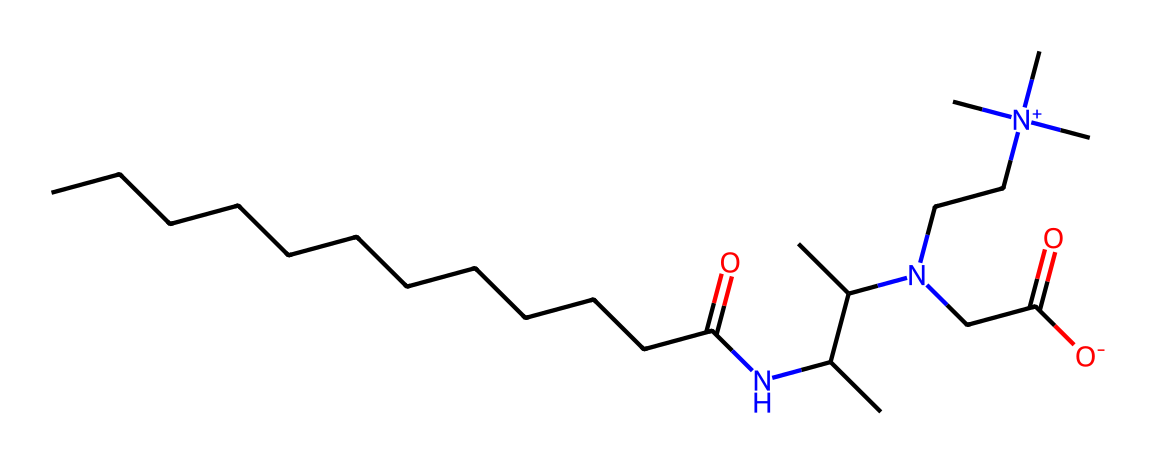What is the molecular formula of cocamidopropyl betaine? By analyzing the molecular structure represented by the provided SMILES, we can count the number of each type of atom present. The structure indicates there are 21 carbons (C), 42 hydrogens (H), 1 nitrogen (N), and 2 oxygens (O). Thus, the molecular formula can be deduced as C21H42N2O2.
Answer: C21H42N2O2 How many nitrogen atoms are in cocamidopropyl betaine? In the SMILES notation, we can identify nitrogen by locating the "N" symbols in the structure. The chemical contains two "N" symbols, indicating there are two nitrogen atoms in the molecular structure.
Answer: 2 What functional groups are present in this surfactant? Upon examining the SMILES structure, we can identify that there are at least two notable functional groups: one amide (-C(=O)N-) and one quaternary ammonium group (-N+(C)(C)(C)). These groups are characteristic of surfactants and contribute to their surfactant properties.
Answer: amide, quaternary ammonium What type of surfactant is cocamidopropyl betaine? Based on its structure, specifically the presence of both a hydrophobic tail (long carbon chain) and a hydrophilic head (containing the amine and carboxylate functional groups), we can classify cocamidopropyl betaine as a zwitterionic surfactant due to containing both positive and negative charge sites.
Answer: zwitterionic How many carbons are in the hydrophobic tail of cocamidopropyl betaine? By reviewing the starting part of the SMILES notation which represents the long hydrocarbon chain, we see there are 12 carbon atoms before the amide structure begins. This indicates that the hydrophobic tail consists of 12 carbons.
Answer: 12 